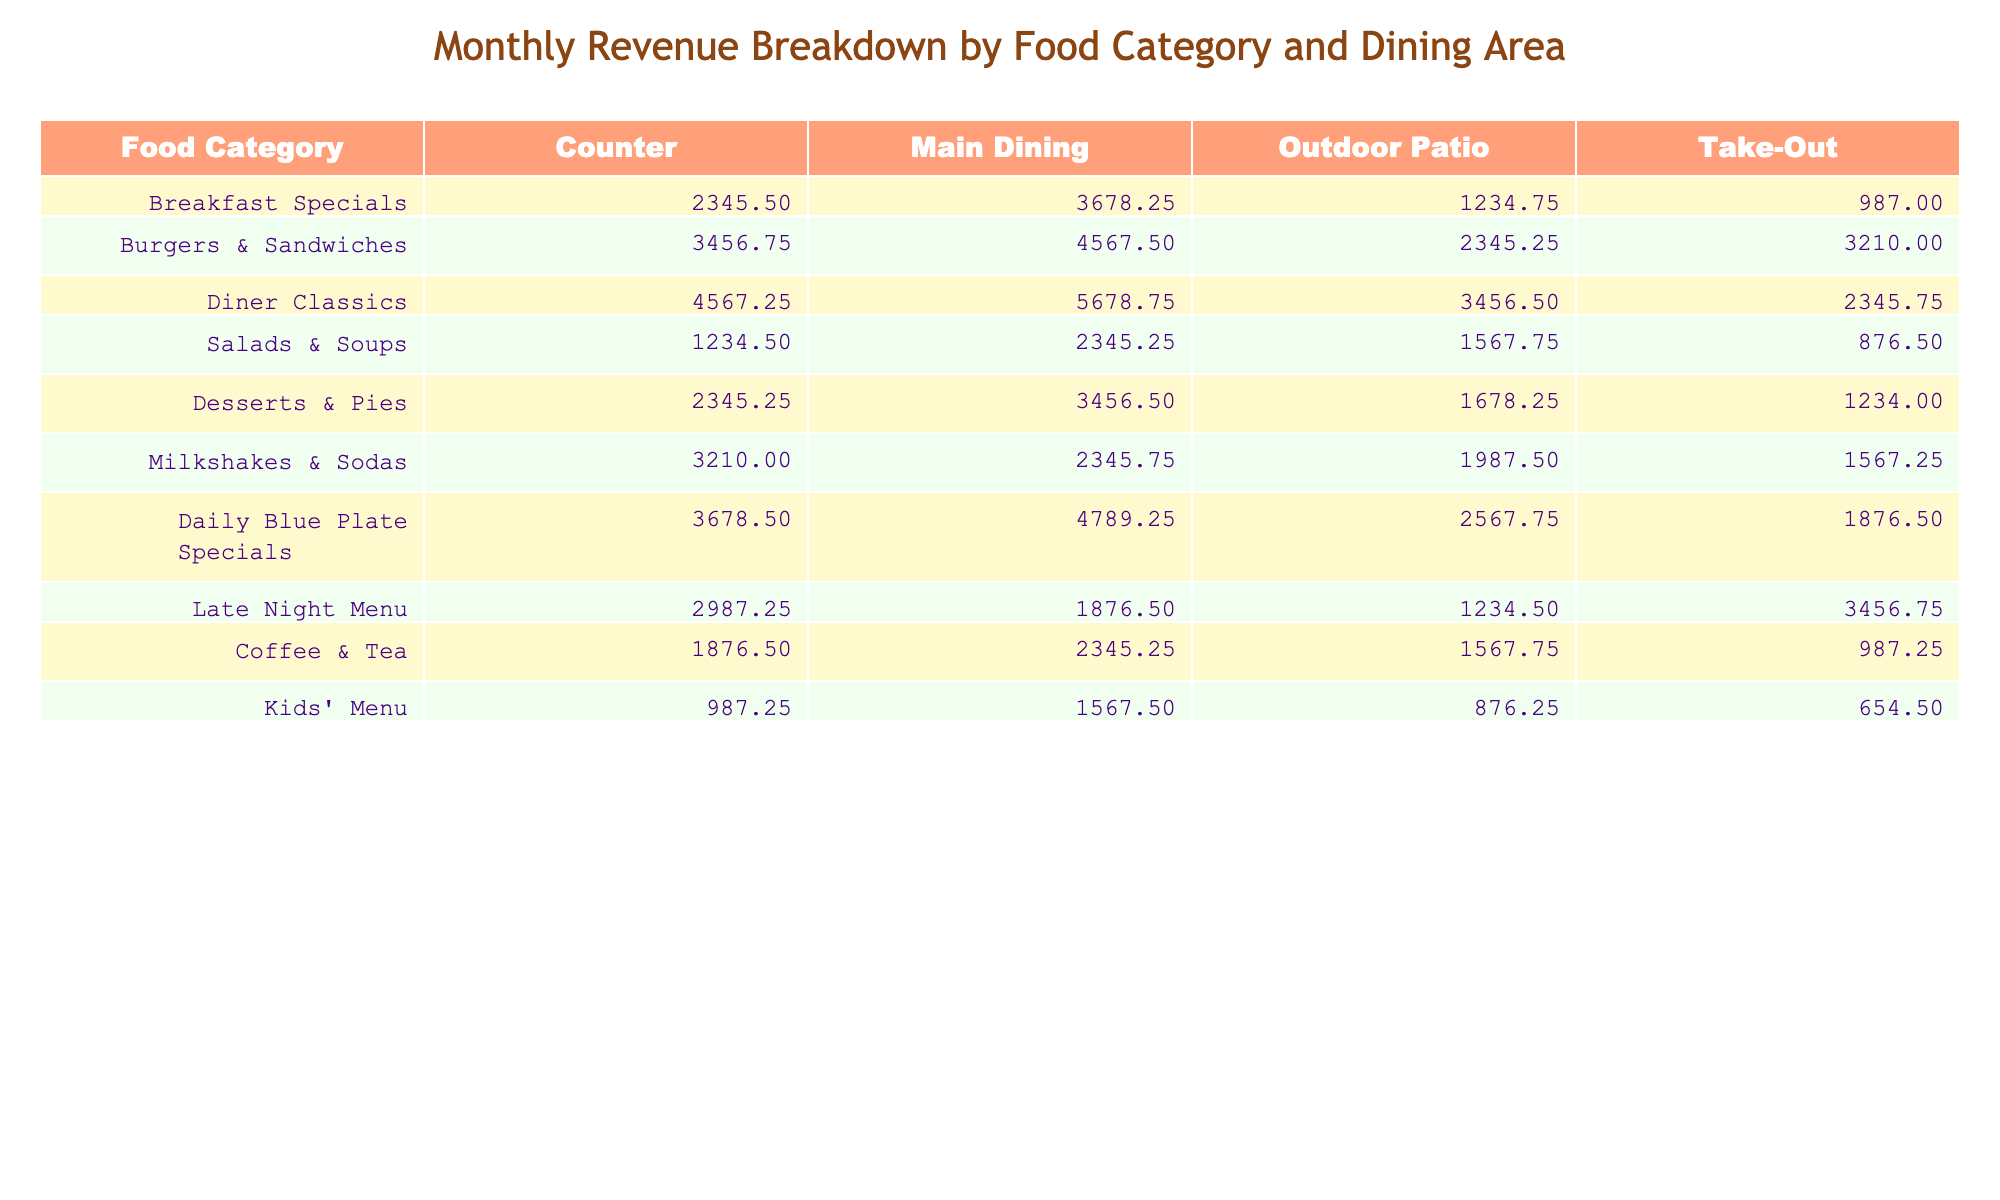What is the total revenue from the "Burgers & Sandwiches" category? Adding the values under the "Burgers & Sandwiches" category (3456.75 + 4567.50 + 2345.25 + 3210.00), the total is calculated as follows: 3456.75 + 4567.50 + 2345.25 + 3210.00 = 13579.50
Answer: 13579.50 Which dining area generated the highest amount of revenue for "Diner Classics"? Looking at the values for "Diner Classics" (4567.25 in Counter, 5678.75 in Main Dining, 3456.50 in Outdoor Patio, and 2345.75 in Take-Out), the highest value is 5678.75 in Main Dining.
Answer: Main Dining Is the revenue for "Salads & Soups" greater than the total revenue for "Coffee & Tea"? First, calculate the total revenue for "Salads & Soups" (1234.50 + 2345.25 + 1567.75 + 876.50 = 6024.00) and for "Coffee & Tea" (1876.50 + 2345.25 + 1567.75 + 987.25 = 6886.75). Comparing both shows that 6024.00 < 6886.75, so the answer is No.
Answer: No What is the average revenue generated from the "Breakfast Specials" category across all dining areas? First, we sum the revenues for "Breakfast Specials" from all areas: 2345.50 + 3678.25 + 1234.75 + 987.00 = 8255.50. Then, we divide this sum by the number of dining areas (4), so 8255.50 / 4 = 2063.875.
Answer: 2063.88 Which food category had the lowest revenue in the "Outdoor Patio"? Reviewing the revenues in the "Outdoor Patio" column, the values are: 1234.75 for "Breakfast Specials", 2345.25 for "Burgers & Sandwiches", 3456.50 for "Diner Classics", 1567.75 for "Salads & Soups", 1678.25 for "Desserts & Pies", 1987.50 for "Milkshakes & Sodas", 2567.75 for "Daily Blue Plate Specials", 1234.50 for "Late Night Menu", 1567.75 for "Coffee & Tea", and 876.25 for "Kids' Menu". The lowest value is 876.25 for "Kids' Menu".
Answer: Kids' Menu What is the total revenue from "Daily Blue Plate Specials" across all dining areas? To find this total, we add the values for "Daily Blue Plate Specials": 3678.50 + 4789.25 + 2567.75 + 1876.50, which calculates to 3678.50 + 4789.25 + 2567.75 + 1876.50 = 12912.00.
Answer: 12912.00 Is it true that the "Late Night Menu" revenue in the Take-Out area is the highest across all categories? The revenue for the "Late Night Menu" in Take-Out is 3456.75. Checking values in the Take-Out column, the amounts are: 987.00, 3210.00, 2345.75, 876.50, 1234.00, 1567.25, 1876.50, 3456.75, and 654.50. The highest amount is 3456.75, so the answer is Yes.
Answer: Yes What is the total revenue from "Desserts & Pies" compared to "Milkshakes & Sodas"? The total revenue for "Desserts & Pies" is (2345.25 + 3456.50 + 1678.25 + 1234.00) = 8254.00 and for "Milkshakes & Sodas" is (3210.00 + 2345.75 + 1987.50 + 1567.25) = 9120.50. Comparing both, 8254.00 < 9120.50, which indicates that "Milkshakes & Sodas" has a higher total.
Answer: Milkshakes & Sodas Which food category had the second highest revenue in the "Main Dining" area? Examining the "Main Dining" values: 3678.25 for "Breakfast Specials", 4567.50 for "Burgers & Sandwiches", 5678.75 for "Diner Classics", 2345.25 for "Salads & Soups", 3456.50 for "Desserts & Pies", 2345.75 for "Milkshakes & Sodas", 4789.25 for "Daily Blue Plate Specials", 1876.50 for "Late Night Menu", 2345.25 for "Coffee & Tea", and 1567.50 for "Kids' Menu". The second highest is 4789.25 for "Daily Blue Plate Specials".
Answer: Daily Blue Plate Specials How much did "Kids' Menu" contribute to total revenue across all areas? To find this, sum the values for "Kids' Menu" in all areas: 987.25 + 1567.50 + 876.25 + 654.50 = 4085.50. Therefore, the total contribution is 4085.50.
Answer: 4085.50 